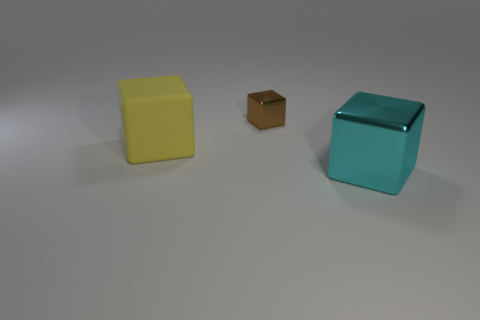What are the different colors of objects present in this image? In the image, there are objects in three distinct colors: a yellow cube, a brown cube, and a cyan cube. 